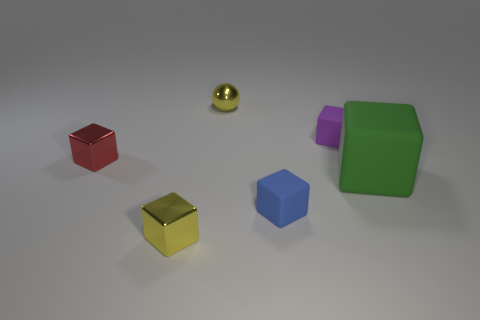Subtract all green matte blocks. How many blocks are left? 4 Subtract 1 blocks. How many blocks are left? 4 Subtract all blue blocks. How many blocks are left? 4 Add 1 small blue rubber cylinders. How many objects exist? 7 Subtract all balls. How many objects are left? 5 Subtract all brown blocks. How many red balls are left? 0 Add 3 red metallic things. How many red metallic things are left? 4 Add 4 tiny red objects. How many tiny red objects exist? 5 Subtract 0 gray balls. How many objects are left? 6 Subtract all cyan balls. Subtract all green cylinders. How many balls are left? 1 